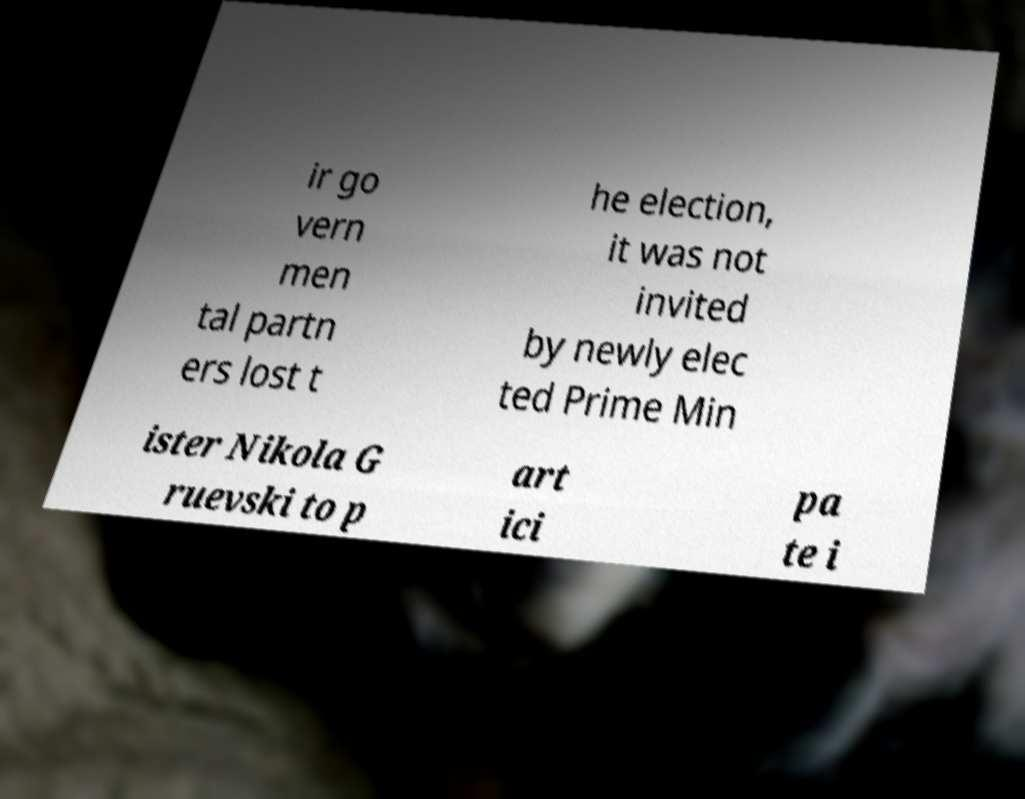There's text embedded in this image that I need extracted. Can you transcribe it verbatim? ir go vern men tal partn ers lost t he election, it was not invited by newly elec ted Prime Min ister Nikola G ruevski to p art ici pa te i 